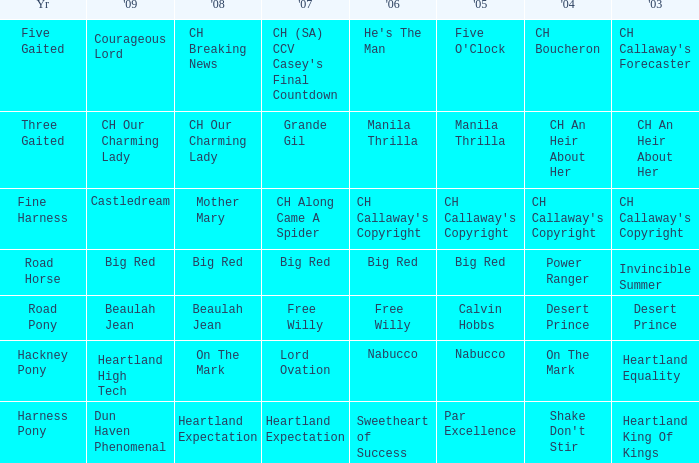What is the 2007 with ch callaway's copyright in 2003? CH Along Came A Spider. 